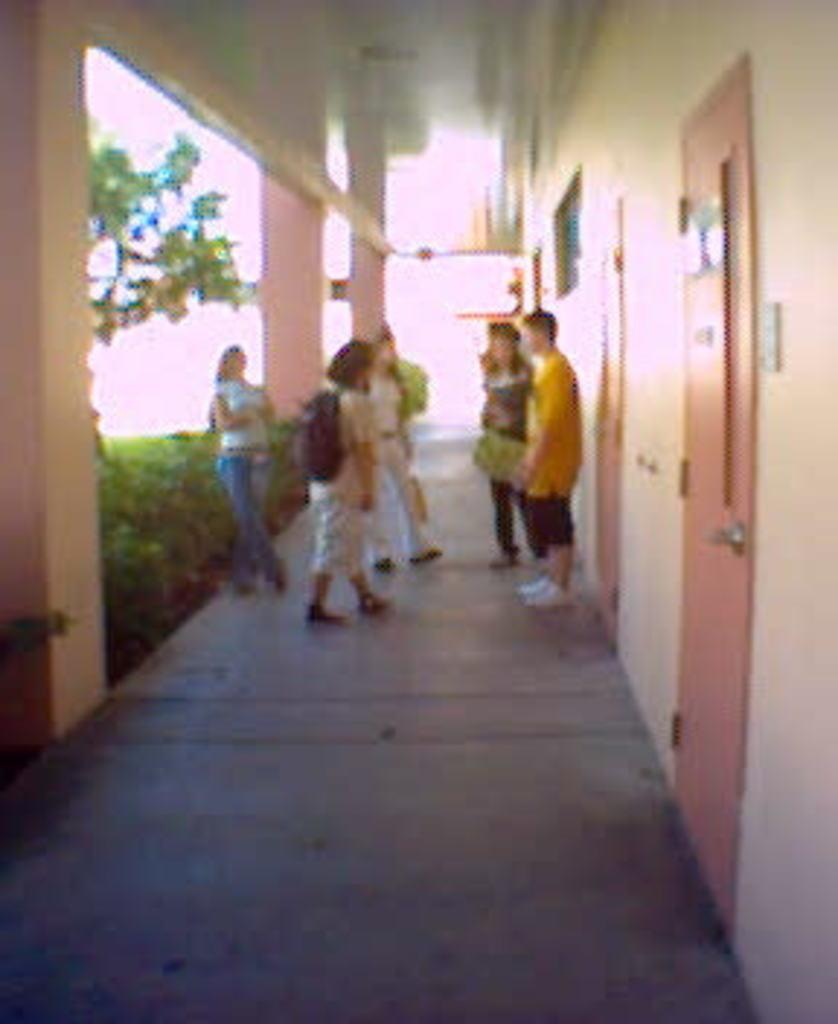What can be seen in the corridor in the image? There are people standing in the corridor in the image. What is on the wall in the image? There is a wall with doors in the image. What architectural features are visible in the image? There are pillars visible in the image. What type of vegetation is present in the image? Plants are present in the image. What type of cherry is being eaten by the boys in the image? There are no boys or cherries present in the image. What is the temper of the people standing in the corridor in the image? The provided facts do not give any information about the temper of the people in the image. 